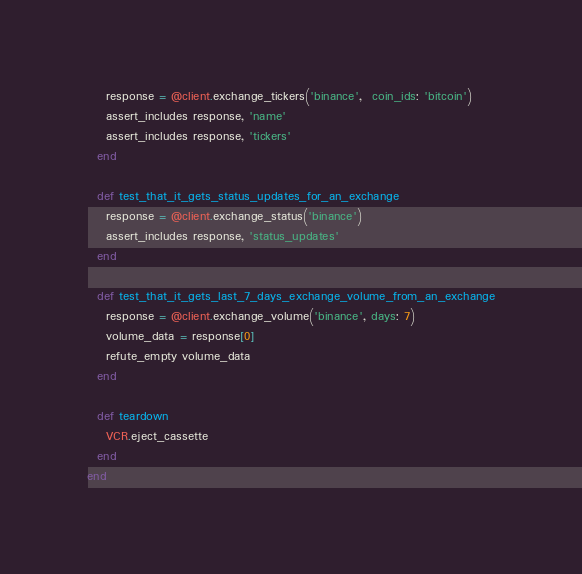<code> <loc_0><loc_0><loc_500><loc_500><_Ruby_>    response = @client.exchange_tickers('binance',  coin_ids: 'bitcoin')
    assert_includes response, 'name'
    assert_includes response, 'tickers'
  end

  def test_that_it_gets_status_updates_for_an_exchange
    response = @client.exchange_status('binance')
    assert_includes response, 'status_updates'
  end

  def test_that_it_gets_last_7_days_exchange_volume_from_an_exchange
    response = @client.exchange_volume('binance', days: 7)
    volume_data = response[0]
    refute_empty volume_data
  end

  def teardown
    VCR.eject_cassette
  end
end
</code> 